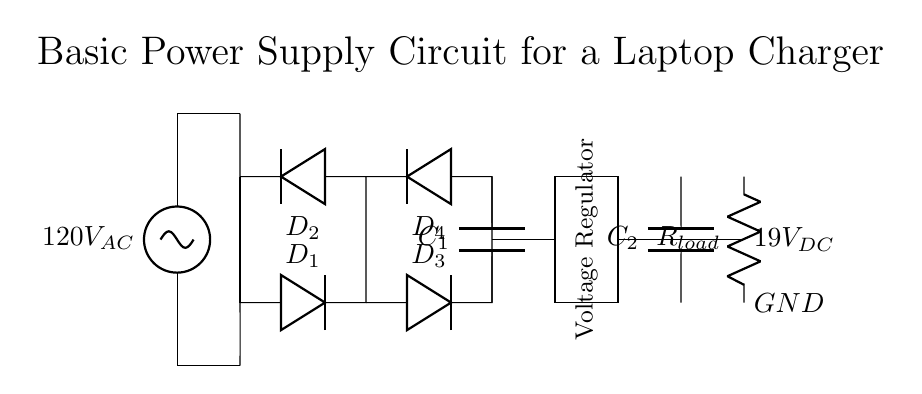What is the input voltage of this circuit? The circuit diagram shows an AC voltage source labeled as 120V AC, which indicates that this is the voltage supplied to the input.
Answer: 120V AC What are the components of the bridge rectifier? The bridge rectifier consists of four diodes labeled as D1, D2, D3, and D4, which work together to convert AC voltage to DC voltage.
Answer: D1, D2, D3, D4 What type of capacitor is shown in the circuit? There are two capacitors in the circuit: C1 is the smoothing capacitor located after the bridge rectifier, and C2 is a filter capacitor before the load resistor. Both are electrolytic capacitors used for stabilizing DC voltage.
Answer: C1, C2 What is the output voltage of the circuit? The output of the circuit is labeled as 19V DC, which is the desired voltage supplied to the load after regulation and smoothing.
Answer: 19V DC What is the purpose of the voltage regulator in this circuit? The voltage regulator is responsible for maintaining a steady output voltage of 19V DC regardless of variations in input voltage or load conditions, which ensures that the laptop receives a consistent power supply.
Answer: Maintain steady voltage How many capacitors are there in total in this circuit? The circuit diagram indicates there are two capacitors, C1 for smoothing after the rectification and C2 which is positioned at the output side to help filter the DC voltage.
Answer: 2 